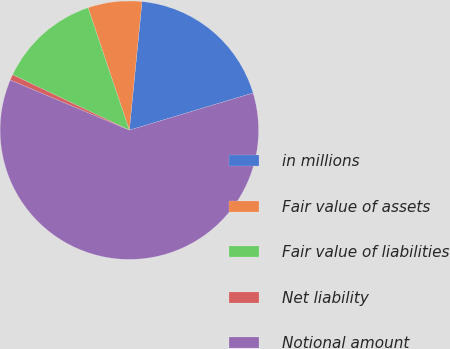<chart> <loc_0><loc_0><loc_500><loc_500><pie_chart><fcel>in millions<fcel>Fair value of assets<fcel>Fair value of liabilities<fcel>Net liability<fcel>Notional amount<nl><fcel>18.79%<fcel>6.74%<fcel>12.77%<fcel>0.71%<fcel>61.0%<nl></chart> 